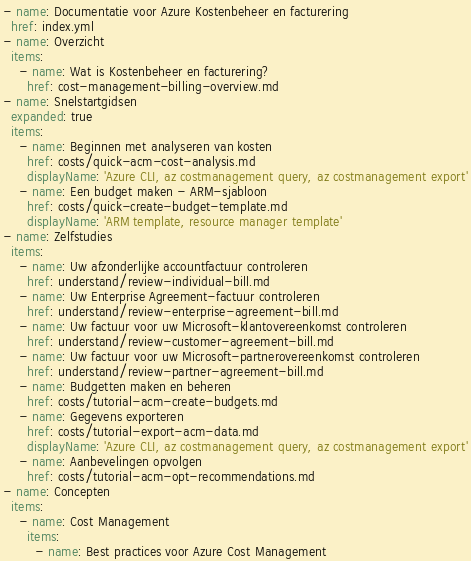Convert code to text. <code><loc_0><loc_0><loc_500><loc_500><_YAML_>- name: Documentatie voor Azure Kostenbeheer en facturering
  href: index.yml
- name: Overzicht
  items:
    - name: Wat is Kostenbeheer en facturering?
      href: cost-management-billing-overview.md
- name: Snelstartgidsen
  expanded: true
  items:
    - name: Beginnen met analyseren van kosten
      href: costs/quick-acm-cost-analysis.md
      displayName: 'Azure CLI, az costmanagement query, az costmanagement export'
    - name: Een budget maken - ARM-sjabloon
      href: costs/quick-create-budget-template.md
      displayName: 'ARM template, resource manager template'
- name: Zelfstudies
  items:
    - name: Uw afzonderlijke accountfactuur controleren
      href: understand/review-individual-bill.md
    - name: Uw Enterprise Agreement-factuur controleren
      href: understand/review-enterprise-agreement-bill.md
    - name: Uw factuur voor uw Microsoft-klantovereenkomst controleren
      href: understand/review-customer-agreement-bill.md
    - name: Uw factuur voor uw Microsoft-partnerovereenkomst controleren
      href: understand/review-partner-agreement-bill.md
    - name: Budgetten maken en beheren
      href: costs/tutorial-acm-create-budgets.md
    - name: Gegevens exporteren
      href: costs/tutorial-export-acm-data.md
      displayName: 'Azure CLI, az costmanagement query, az costmanagement export'
    - name: Aanbevelingen opvolgen
      href: costs/tutorial-acm-opt-recommendations.md
- name: Concepten
  items:
    - name: Cost Management
      items:
        - name: Best practices voor Azure Cost Management</code> 